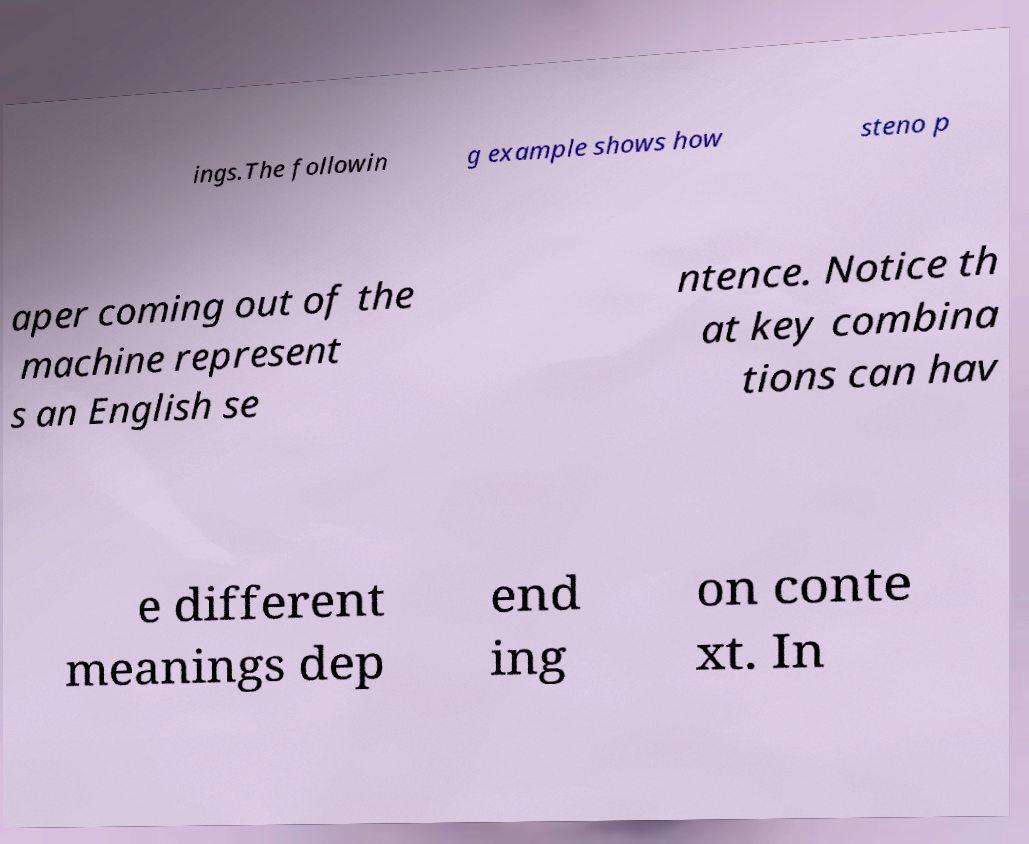Please read and relay the text visible in this image. What does it say? ings.The followin g example shows how steno p aper coming out of the machine represent s an English se ntence. Notice th at key combina tions can hav e different meanings dep end ing on conte xt. In 